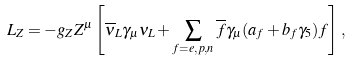<formula> <loc_0><loc_0><loc_500><loc_500>L _ { Z } = - g _ { Z } Z ^ { \mu } \left [ \overline { \nu } _ { L } \gamma _ { \mu } \nu _ { L } + \sum _ { f = e , p , n } \overline { f } \gamma _ { \mu } ( a _ { f } + b _ { f } \gamma _ { 5 } ) f \right ] \, ,</formula> 